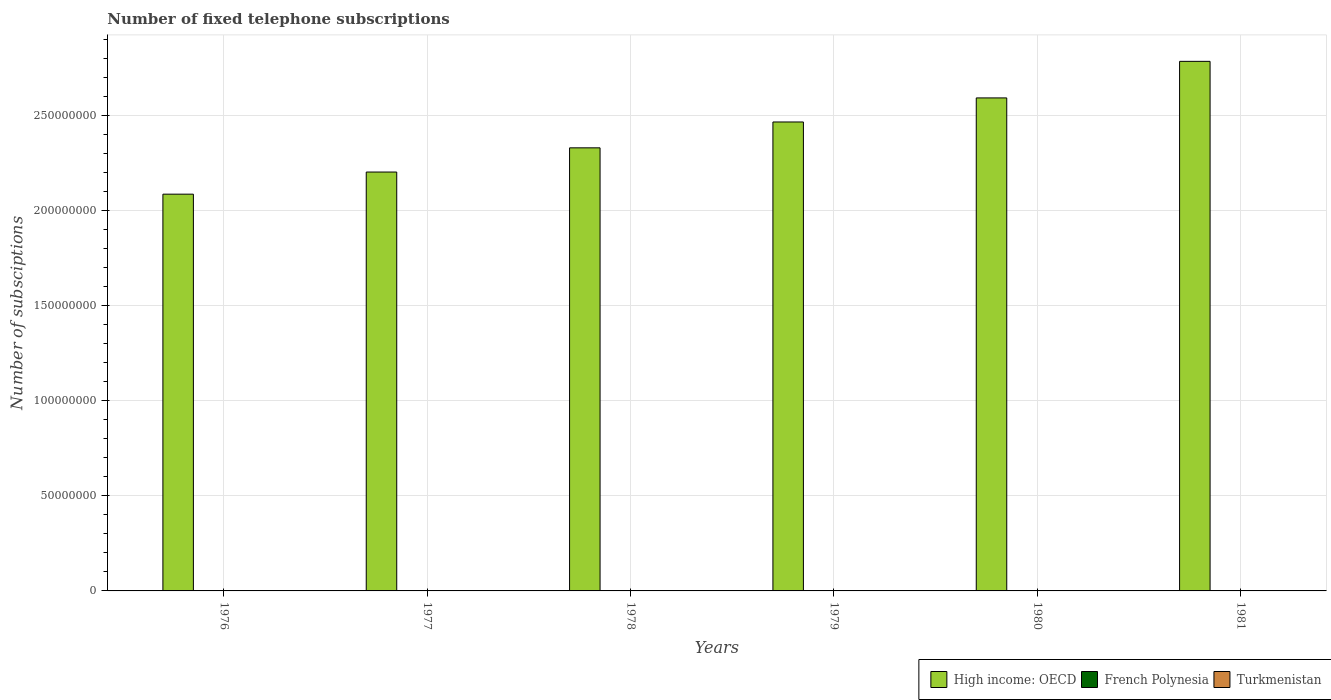How many different coloured bars are there?
Offer a terse response. 3. How many groups of bars are there?
Give a very brief answer. 6. Are the number of bars per tick equal to the number of legend labels?
Keep it short and to the point. Yes. Are the number of bars on each tick of the X-axis equal?
Give a very brief answer. Yes. How many bars are there on the 1st tick from the left?
Your answer should be very brief. 3. How many bars are there on the 2nd tick from the right?
Ensure brevity in your answer.  3. What is the label of the 4th group of bars from the left?
Your response must be concise. 1979. In how many cases, is the number of bars for a given year not equal to the number of legend labels?
Offer a terse response. 0. What is the number of fixed telephone subscriptions in French Polynesia in 1979?
Your answer should be very brief. 1.10e+04. Across all years, what is the minimum number of fixed telephone subscriptions in High income: OECD?
Provide a short and direct response. 2.09e+08. In which year was the number of fixed telephone subscriptions in French Polynesia minimum?
Provide a short and direct response. 1976. What is the total number of fixed telephone subscriptions in High income: OECD in the graph?
Give a very brief answer. 1.45e+09. What is the difference between the number of fixed telephone subscriptions in French Polynesia in 1976 and that in 1977?
Keep it short and to the point. -1000. What is the difference between the number of fixed telephone subscriptions in French Polynesia in 1977 and the number of fixed telephone subscriptions in High income: OECD in 1980?
Your response must be concise. -2.59e+08. What is the average number of fixed telephone subscriptions in French Polynesia per year?
Give a very brief answer. 1.06e+04. In the year 1978, what is the difference between the number of fixed telephone subscriptions in High income: OECD and number of fixed telephone subscriptions in Turkmenistan?
Give a very brief answer. 2.33e+08. In how many years, is the number of fixed telephone subscriptions in Turkmenistan greater than 140000000?
Offer a very short reply. 0. What is the ratio of the number of fixed telephone subscriptions in High income: OECD in 1979 to that in 1980?
Your response must be concise. 0.95. Is the difference between the number of fixed telephone subscriptions in High income: OECD in 1976 and 1977 greater than the difference between the number of fixed telephone subscriptions in Turkmenistan in 1976 and 1977?
Make the answer very short. No. What is the difference between the highest and the lowest number of fixed telephone subscriptions in French Polynesia?
Offer a terse response. 5200. In how many years, is the number of fixed telephone subscriptions in French Polynesia greater than the average number of fixed telephone subscriptions in French Polynesia taken over all years?
Your answer should be compact. 3. What does the 1st bar from the left in 1977 represents?
Offer a terse response. High income: OECD. What does the 1st bar from the right in 1980 represents?
Provide a short and direct response. Turkmenistan. Is it the case that in every year, the sum of the number of fixed telephone subscriptions in French Polynesia and number of fixed telephone subscriptions in High income: OECD is greater than the number of fixed telephone subscriptions in Turkmenistan?
Offer a terse response. Yes. How many bars are there?
Your answer should be very brief. 18. Are all the bars in the graph horizontal?
Give a very brief answer. No. What is the difference between two consecutive major ticks on the Y-axis?
Ensure brevity in your answer.  5.00e+07. Are the values on the major ticks of Y-axis written in scientific E-notation?
Give a very brief answer. No. Does the graph contain grids?
Make the answer very short. Yes. Where does the legend appear in the graph?
Your answer should be compact. Bottom right. How are the legend labels stacked?
Give a very brief answer. Horizontal. What is the title of the graph?
Keep it short and to the point. Number of fixed telephone subscriptions. What is the label or title of the Y-axis?
Your response must be concise. Number of subsciptions. What is the Number of subsciptions of High income: OECD in 1976?
Your answer should be compact. 2.09e+08. What is the Number of subsciptions of French Polynesia in 1976?
Offer a very short reply. 8000. What is the Number of subsciptions of Turkmenistan in 1976?
Keep it short and to the point. 7.00e+04. What is the Number of subsciptions of High income: OECD in 1977?
Give a very brief answer. 2.20e+08. What is the Number of subsciptions of French Polynesia in 1977?
Offer a very short reply. 9000. What is the Number of subsciptions in High income: OECD in 1978?
Your answer should be compact. 2.33e+08. What is the Number of subsciptions of French Polynesia in 1978?
Give a very brief answer. 10000. What is the Number of subsciptions in High income: OECD in 1979?
Offer a very short reply. 2.47e+08. What is the Number of subsciptions in French Polynesia in 1979?
Your answer should be compact. 1.10e+04. What is the Number of subsciptions of Turkmenistan in 1979?
Keep it short and to the point. 1.00e+05. What is the Number of subsciptions in High income: OECD in 1980?
Give a very brief answer. 2.59e+08. What is the Number of subsciptions in French Polynesia in 1980?
Keep it short and to the point. 1.25e+04. What is the Number of subsciptions in Turkmenistan in 1980?
Keep it short and to the point. 1.10e+05. What is the Number of subsciptions of High income: OECD in 1981?
Offer a very short reply. 2.79e+08. What is the Number of subsciptions of French Polynesia in 1981?
Offer a very short reply. 1.32e+04. What is the Number of subsciptions in Turkmenistan in 1981?
Your answer should be very brief. 1.20e+05. Across all years, what is the maximum Number of subsciptions in High income: OECD?
Offer a very short reply. 2.79e+08. Across all years, what is the maximum Number of subsciptions of French Polynesia?
Make the answer very short. 1.32e+04. Across all years, what is the minimum Number of subsciptions in High income: OECD?
Keep it short and to the point. 2.09e+08. Across all years, what is the minimum Number of subsciptions of French Polynesia?
Provide a short and direct response. 8000. What is the total Number of subsciptions of High income: OECD in the graph?
Your response must be concise. 1.45e+09. What is the total Number of subsciptions in French Polynesia in the graph?
Your answer should be compact. 6.37e+04. What is the total Number of subsciptions in Turkmenistan in the graph?
Keep it short and to the point. 5.70e+05. What is the difference between the Number of subsciptions in High income: OECD in 1976 and that in 1977?
Offer a very short reply. -1.16e+07. What is the difference between the Number of subsciptions of French Polynesia in 1976 and that in 1977?
Offer a terse response. -1000. What is the difference between the Number of subsciptions of Turkmenistan in 1976 and that in 1977?
Your answer should be very brief. -10000. What is the difference between the Number of subsciptions in High income: OECD in 1976 and that in 1978?
Ensure brevity in your answer.  -2.44e+07. What is the difference between the Number of subsciptions of French Polynesia in 1976 and that in 1978?
Give a very brief answer. -2000. What is the difference between the Number of subsciptions in High income: OECD in 1976 and that in 1979?
Provide a short and direct response. -3.80e+07. What is the difference between the Number of subsciptions in French Polynesia in 1976 and that in 1979?
Your answer should be compact. -3000. What is the difference between the Number of subsciptions in Turkmenistan in 1976 and that in 1979?
Make the answer very short. -3.00e+04. What is the difference between the Number of subsciptions in High income: OECD in 1976 and that in 1980?
Offer a very short reply. -5.07e+07. What is the difference between the Number of subsciptions in French Polynesia in 1976 and that in 1980?
Give a very brief answer. -4500. What is the difference between the Number of subsciptions in High income: OECD in 1976 and that in 1981?
Offer a terse response. -6.99e+07. What is the difference between the Number of subsciptions of French Polynesia in 1976 and that in 1981?
Offer a very short reply. -5200. What is the difference between the Number of subsciptions in High income: OECD in 1977 and that in 1978?
Ensure brevity in your answer.  -1.27e+07. What is the difference between the Number of subsciptions of French Polynesia in 1977 and that in 1978?
Give a very brief answer. -1000. What is the difference between the Number of subsciptions in High income: OECD in 1977 and that in 1979?
Give a very brief answer. -2.63e+07. What is the difference between the Number of subsciptions in French Polynesia in 1977 and that in 1979?
Give a very brief answer. -2000. What is the difference between the Number of subsciptions of Turkmenistan in 1977 and that in 1979?
Make the answer very short. -2.00e+04. What is the difference between the Number of subsciptions of High income: OECD in 1977 and that in 1980?
Your answer should be compact. -3.90e+07. What is the difference between the Number of subsciptions in French Polynesia in 1977 and that in 1980?
Your answer should be compact. -3500. What is the difference between the Number of subsciptions in High income: OECD in 1977 and that in 1981?
Give a very brief answer. -5.82e+07. What is the difference between the Number of subsciptions in French Polynesia in 1977 and that in 1981?
Give a very brief answer. -4200. What is the difference between the Number of subsciptions of High income: OECD in 1978 and that in 1979?
Your answer should be compact. -1.36e+07. What is the difference between the Number of subsciptions in French Polynesia in 1978 and that in 1979?
Provide a short and direct response. -1000. What is the difference between the Number of subsciptions of Turkmenistan in 1978 and that in 1979?
Your response must be concise. -10000. What is the difference between the Number of subsciptions of High income: OECD in 1978 and that in 1980?
Offer a terse response. -2.63e+07. What is the difference between the Number of subsciptions of French Polynesia in 1978 and that in 1980?
Give a very brief answer. -2500. What is the difference between the Number of subsciptions of Turkmenistan in 1978 and that in 1980?
Provide a succinct answer. -2.00e+04. What is the difference between the Number of subsciptions in High income: OECD in 1978 and that in 1981?
Provide a short and direct response. -4.55e+07. What is the difference between the Number of subsciptions of French Polynesia in 1978 and that in 1981?
Your answer should be compact. -3200. What is the difference between the Number of subsciptions of High income: OECD in 1979 and that in 1980?
Keep it short and to the point. -1.27e+07. What is the difference between the Number of subsciptions of French Polynesia in 1979 and that in 1980?
Keep it short and to the point. -1500. What is the difference between the Number of subsciptions of High income: OECD in 1979 and that in 1981?
Your answer should be compact. -3.19e+07. What is the difference between the Number of subsciptions of French Polynesia in 1979 and that in 1981?
Offer a terse response. -2200. What is the difference between the Number of subsciptions of High income: OECD in 1980 and that in 1981?
Keep it short and to the point. -1.92e+07. What is the difference between the Number of subsciptions in French Polynesia in 1980 and that in 1981?
Provide a succinct answer. -700. What is the difference between the Number of subsciptions of High income: OECD in 1976 and the Number of subsciptions of French Polynesia in 1977?
Provide a short and direct response. 2.09e+08. What is the difference between the Number of subsciptions of High income: OECD in 1976 and the Number of subsciptions of Turkmenistan in 1977?
Your response must be concise. 2.09e+08. What is the difference between the Number of subsciptions of French Polynesia in 1976 and the Number of subsciptions of Turkmenistan in 1977?
Provide a succinct answer. -7.20e+04. What is the difference between the Number of subsciptions of High income: OECD in 1976 and the Number of subsciptions of French Polynesia in 1978?
Give a very brief answer. 2.09e+08. What is the difference between the Number of subsciptions in High income: OECD in 1976 and the Number of subsciptions in Turkmenistan in 1978?
Your answer should be compact. 2.09e+08. What is the difference between the Number of subsciptions in French Polynesia in 1976 and the Number of subsciptions in Turkmenistan in 1978?
Your response must be concise. -8.20e+04. What is the difference between the Number of subsciptions of High income: OECD in 1976 and the Number of subsciptions of French Polynesia in 1979?
Your answer should be very brief. 2.09e+08. What is the difference between the Number of subsciptions of High income: OECD in 1976 and the Number of subsciptions of Turkmenistan in 1979?
Your response must be concise. 2.09e+08. What is the difference between the Number of subsciptions of French Polynesia in 1976 and the Number of subsciptions of Turkmenistan in 1979?
Your answer should be compact. -9.20e+04. What is the difference between the Number of subsciptions in High income: OECD in 1976 and the Number of subsciptions in French Polynesia in 1980?
Offer a terse response. 2.09e+08. What is the difference between the Number of subsciptions of High income: OECD in 1976 and the Number of subsciptions of Turkmenistan in 1980?
Your answer should be very brief. 2.09e+08. What is the difference between the Number of subsciptions of French Polynesia in 1976 and the Number of subsciptions of Turkmenistan in 1980?
Give a very brief answer. -1.02e+05. What is the difference between the Number of subsciptions of High income: OECD in 1976 and the Number of subsciptions of French Polynesia in 1981?
Your answer should be very brief. 2.09e+08. What is the difference between the Number of subsciptions in High income: OECD in 1976 and the Number of subsciptions in Turkmenistan in 1981?
Offer a very short reply. 2.09e+08. What is the difference between the Number of subsciptions in French Polynesia in 1976 and the Number of subsciptions in Turkmenistan in 1981?
Give a very brief answer. -1.12e+05. What is the difference between the Number of subsciptions of High income: OECD in 1977 and the Number of subsciptions of French Polynesia in 1978?
Your answer should be compact. 2.20e+08. What is the difference between the Number of subsciptions of High income: OECD in 1977 and the Number of subsciptions of Turkmenistan in 1978?
Your response must be concise. 2.20e+08. What is the difference between the Number of subsciptions in French Polynesia in 1977 and the Number of subsciptions in Turkmenistan in 1978?
Give a very brief answer. -8.10e+04. What is the difference between the Number of subsciptions of High income: OECD in 1977 and the Number of subsciptions of French Polynesia in 1979?
Your answer should be compact. 2.20e+08. What is the difference between the Number of subsciptions of High income: OECD in 1977 and the Number of subsciptions of Turkmenistan in 1979?
Provide a short and direct response. 2.20e+08. What is the difference between the Number of subsciptions in French Polynesia in 1977 and the Number of subsciptions in Turkmenistan in 1979?
Provide a short and direct response. -9.10e+04. What is the difference between the Number of subsciptions in High income: OECD in 1977 and the Number of subsciptions in French Polynesia in 1980?
Offer a terse response. 2.20e+08. What is the difference between the Number of subsciptions in High income: OECD in 1977 and the Number of subsciptions in Turkmenistan in 1980?
Keep it short and to the point. 2.20e+08. What is the difference between the Number of subsciptions in French Polynesia in 1977 and the Number of subsciptions in Turkmenistan in 1980?
Keep it short and to the point. -1.01e+05. What is the difference between the Number of subsciptions of High income: OECD in 1977 and the Number of subsciptions of French Polynesia in 1981?
Offer a terse response. 2.20e+08. What is the difference between the Number of subsciptions of High income: OECD in 1977 and the Number of subsciptions of Turkmenistan in 1981?
Your answer should be very brief. 2.20e+08. What is the difference between the Number of subsciptions of French Polynesia in 1977 and the Number of subsciptions of Turkmenistan in 1981?
Offer a terse response. -1.11e+05. What is the difference between the Number of subsciptions of High income: OECD in 1978 and the Number of subsciptions of French Polynesia in 1979?
Give a very brief answer. 2.33e+08. What is the difference between the Number of subsciptions in High income: OECD in 1978 and the Number of subsciptions in Turkmenistan in 1979?
Your answer should be very brief. 2.33e+08. What is the difference between the Number of subsciptions in High income: OECD in 1978 and the Number of subsciptions in French Polynesia in 1980?
Provide a succinct answer. 2.33e+08. What is the difference between the Number of subsciptions of High income: OECD in 1978 and the Number of subsciptions of Turkmenistan in 1980?
Provide a short and direct response. 2.33e+08. What is the difference between the Number of subsciptions of High income: OECD in 1978 and the Number of subsciptions of French Polynesia in 1981?
Make the answer very short. 2.33e+08. What is the difference between the Number of subsciptions of High income: OECD in 1978 and the Number of subsciptions of Turkmenistan in 1981?
Ensure brevity in your answer.  2.33e+08. What is the difference between the Number of subsciptions of High income: OECD in 1979 and the Number of subsciptions of French Polynesia in 1980?
Your response must be concise. 2.47e+08. What is the difference between the Number of subsciptions of High income: OECD in 1979 and the Number of subsciptions of Turkmenistan in 1980?
Provide a short and direct response. 2.47e+08. What is the difference between the Number of subsciptions in French Polynesia in 1979 and the Number of subsciptions in Turkmenistan in 1980?
Ensure brevity in your answer.  -9.90e+04. What is the difference between the Number of subsciptions in High income: OECD in 1979 and the Number of subsciptions in French Polynesia in 1981?
Provide a succinct answer. 2.47e+08. What is the difference between the Number of subsciptions in High income: OECD in 1979 and the Number of subsciptions in Turkmenistan in 1981?
Make the answer very short. 2.47e+08. What is the difference between the Number of subsciptions of French Polynesia in 1979 and the Number of subsciptions of Turkmenistan in 1981?
Offer a terse response. -1.09e+05. What is the difference between the Number of subsciptions in High income: OECD in 1980 and the Number of subsciptions in French Polynesia in 1981?
Give a very brief answer. 2.59e+08. What is the difference between the Number of subsciptions in High income: OECD in 1980 and the Number of subsciptions in Turkmenistan in 1981?
Offer a terse response. 2.59e+08. What is the difference between the Number of subsciptions of French Polynesia in 1980 and the Number of subsciptions of Turkmenistan in 1981?
Offer a terse response. -1.08e+05. What is the average Number of subsciptions in High income: OECD per year?
Your response must be concise. 2.41e+08. What is the average Number of subsciptions of French Polynesia per year?
Provide a short and direct response. 1.06e+04. What is the average Number of subsciptions in Turkmenistan per year?
Provide a short and direct response. 9.50e+04. In the year 1976, what is the difference between the Number of subsciptions of High income: OECD and Number of subsciptions of French Polynesia?
Your answer should be compact. 2.09e+08. In the year 1976, what is the difference between the Number of subsciptions of High income: OECD and Number of subsciptions of Turkmenistan?
Keep it short and to the point. 2.09e+08. In the year 1976, what is the difference between the Number of subsciptions in French Polynesia and Number of subsciptions in Turkmenistan?
Your answer should be compact. -6.20e+04. In the year 1977, what is the difference between the Number of subsciptions of High income: OECD and Number of subsciptions of French Polynesia?
Provide a succinct answer. 2.20e+08. In the year 1977, what is the difference between the Number of subsciptions of High income: OECD and Number of subsciptions of Turkmenistan?
Keep it short and to the point. 2.20e+08. In the year 1977, what is the difference between the Number of subsciptions of French Polynesia and Number of subsciptions of Turkmenistan?
Your response must be concise. -7.10e+04. In the year 1978, what is the difference between the Number of subsciptions in High income: OECD and Number of subsciptions in French Polynesia?
Ensure brevity in your answer.  2.33e+08. In the year 1978, what is the difference between the Number of subsciptions in High income: OECD and Number of subsciptions in Turkmenistan?
Offer a very short reply. 2.33e+08. In the year 1979, what is the difference between the Number of subsciptions of High income: OECD and Number of subsciptions of French Polynesia?
Your answer should be compact. 2.47e+08. In the year 1979, what is the difference between the Number of subsciptions in High income: OECD and Number of subsciptions in Turkmenistan?
Provide a succinct answer. 2.47e+08. In the year 1979, what is the difference between the Number of subsciptions in French Polynesia and Number of subsciptions in Turkmenistan?
Give a very brief answer. -8.90e+04. In the year 1980, what is the difference between the Number of subsciptions of High income: OECD and Number of subsciptions of French Polynesia?
Your response must be concise. 2.59e+08. In the year 1980, what is the difference between the Number of subsciptions of High income: OECD and Number of subsciptions of Turkmenistan?
Your response must be concise. 2.59e+08. In the year 1980, what is the difference between the Number of subsciptions of French Polynesia and Number of subsciptions of Turkmenistan?
Keep it short and to the point. -9.75e+04. In the year 1981, what is the difference between the Number of subsciptions in High income: OECD and Number of subsciptions in French Polynesia?
Offer a terse response. 2.79e+08. In the year 1981, what is the difference between the Number of subsciptions of High income: OECD and Number of subsciptions of Turkmenistan?
Provide a succinct answer. 2.79e+08. In the year 1981, what is the difference between the Number of subsciptions in French Polynesia and Number of subsciptions in Turkmenistan?
Provide a succinct answer. -1.07e+05. What is the ratio of the Number of subsciptions in High income: OECD in 1976 to that in 1977?
Your response must be concise. 0.95. What is the ratio of the Number of subsciptions of French Polynesia in 1976 to that in 1977?
Make the answer very short. 0.89. What is the ratio of the Number of subsciptions in Turkmenistan in 1976 to that in 1977?
Provide a succinct answer. 0.88. What is the ratio of the Number of subsciptions in High income: OECD in 1976 to that in 1978?
Give a very brief answer. 0.9. What is the ratio of the Number of subsciptions in High income: OECD in 1976 to that in 1979?
Offer a very short reply. 0.85. What is the ratio of the Number of subsciptions in French Polynesia in 1976 to that in 1979?
Ensure brevity in your answer.  0.73. What is the ratio of the Number of subsciptions in Turkmenistan in 1976 to that in 1979?
Your answer should be compact. 0.7. What is the ratio of the Number of subsciptions of High income: OECD in 1976 to that in 1980?
Your response must be concise. 0.8. What is the ratio of the Number of subsciptions in French Polynesia in 1976 to that in 1980?
Keep it short and to the point. 0.64. What is the ratio of the Number of subsciptions in Turkmenistan in 1976 to that in 1980?
Your answer should be compact. 0.64. What is the ratio of the Number of subsciptions of High income: OECD in 1976 to that in 1981?
Your answer should be very brief. 0.75. What is the ratio of the Number of subsciptions of French Polynesia in 1976 to that in 1981?
Make the answer very short. 0.61. What is the ratio of the Number of subsciptions of Turkmenistan in 1976 to that in 1981?
Your answer should be very brief. 0.58. What is the ratio of the Number of subsciptions in High income: OECD in 1977 to that in 1978?
Ensure brevity in your answer.  0.95. What is the ratio of the Number of subsciptions in Turkmenistan in 1977 to that in 1978?
Offer a very short reply. 0.89. What is the ratio of the Number of subsciptions in High income: OECD in 1977 to that in 1979?
Provide a succinct answer. 0.89. What is the ratio of the Number of subsciptions in French Polynesia in 1977 to that in 1979?
Offer a very short reply. 0.82. What is the ratio of the Number of subsciptions in Turkmenistan in 1977 to that in 1979?
Make the answer very short. 0.8. What is the ratio of the Number of subsciptions in High income: OECD in 1977 to that in 1980?
Your response must be concise. 0.85. What is the ratio of the Number of subsciptions in French Polynesia in 1977 to that in 1980?
Offer a terse response. 0.72. What is the ratio of the Number of subsciptions of Turkmenistan in 1977 to that in 1980?
Make the answer very short. 0.73. What is the ratio of the Number of subsciptions in High income: OECD in 1977 to that in 1981?
Offer a very short reply. 0.79. What is the ratio of the Number of subsciptions of French Polynesia in 1977 to that in 1981?
Make the answer very short. 0.68. What is the ratio of the Number of subsciptions in High income: OECD in 1978 to that in 1979?
Provide a short and direct response. 0.94. What is the ratio of the Number of subsciptions in French Polynesia in 1978 to that in 1979?
Your answer should be very brief. 0.91. What is the ratio of the Number of subsciptions of High income: OECD in 1978 to that in 1980?
Offer a terse response. 0.9. What is the ratio of the Number of subsciptions of French Polynesia in 1978 to that in 1980?
Your answer should be compact. 0.8. What is the ratio of the Number of subsciptions of Turkmenistan in 1978 to that in 1980?
Offer a terse response. 0.82. What is the ratio of the Number of subsciptions in High income: OECD in 1978 to that in 1981?
Ensure brevity in your answer.  0.84. What is the ratio of the Number of subsciptions of French Polynesia in 1978 to that in 1981?
Provide a short and direct response. 0.76. What is the ratio of the Number of subsciptions in Turkmenistan in 1978 to that in 1981?
Provide a short and direct response. 0.75. What is the ratio of the Number of subsciptions in High income: OECD in 1979 to that in 1980?
Your answer should be compact. 0.95. What is the ratio of the Number of subsciptions of French Polynesia in 1979 to that in 1980?
Provide a short and direct response. 0.88. What is the ratio of the Number of subsciptions in High income: OECD in 1979 to that in 1981?
Offer a very short reply. 0.89. What is the ratio of the Number of subsciptions of French Polynesia in 1979 to that in 1981?
Provide a succinct answer. 0.83. What is the ratio of the Number of subsciptions in French Polynesia in 1980 to that in 1981?
Offer a very short reply. 0.95. What is the ratio of the Number of subsciptions in Turkmenistan in 1980 to that in 1981?
Your answer should be compact. 0.92. What is the difference between the highest and the second highest Number of subsciptions of High income: OECD?
Make the answer very short. 1.92e+07. What is the difference between the highest and the second highest Number of subsciptions of French Polynesia?
Give a very brief answer. 700. What is the difference between the highest and the second highest Number of subsciptions of Turkmenistan?
Your response must be concise. 10000. What is the difference between the highest and the lowest Number of subsciptions of High income: OECD?
Provide a succinct answer. 6.99e+07. What is the difference between the highest and the lowest Number of subsciptions in French Polynesia?
Keep it short and to the point. 5200. What is the difference between the highest and the lowest Number of subsciptions in Turkmenistan?
Provide a short and direct response. 5.00e+04. 